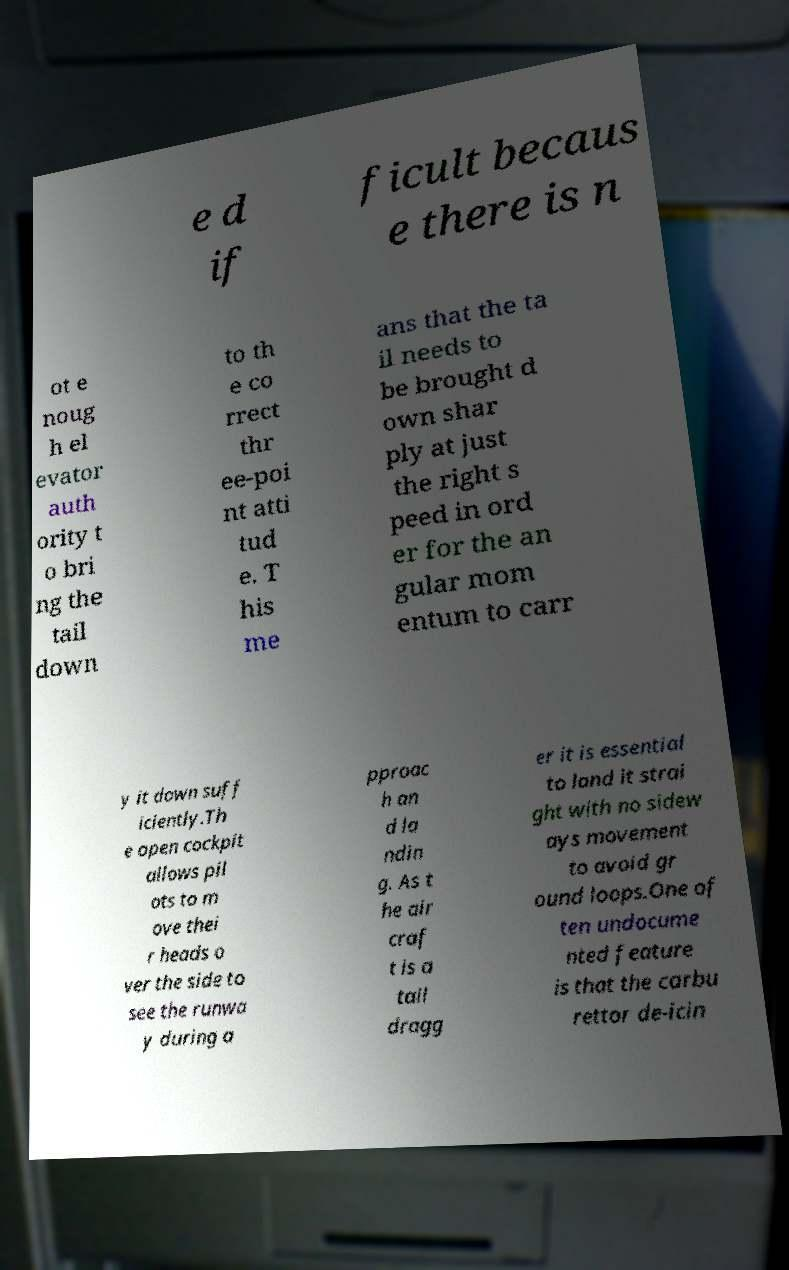Can you read and provide the text displayed in the image?This photo seems to have some interesting text. Can you extract and type it out for me? e d if ficult becaus e there is n ot e noug h el evator auth ority t o bri ng the tail down to th e co rrect thr ee-poi nt atti tud e. T his me ans that the ta il needs to be brought d own shar ply at just the right s peed in ord er for the an gular mom entum to carr y it down suff iciently.Th e open cockpit allows pil ots to m ove thei r heads o ver the side to see the runwa y during a pproac h an d la ndin g. As t he air craf t is a tail dragg er it is essential to land it strai ght with no sidew ays movement to avoid gr ound loops.One of ten undocume nted feature is that the carbu rettor de-icin 